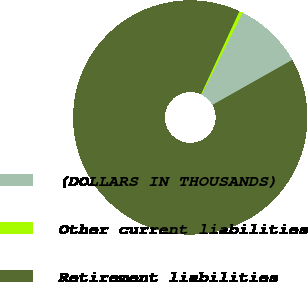Convert chart to OTSL. <chart><loc_0><loc_0><loc_500><loc_500><pie_chart><fcel>(DOLLARS IN THOUSANDS)<fcel>Other current liabilities<fcel>Retirement liabilities<nl><fcel>9.45%<fcel>0.49%<fcel>90.07%<nl></chart> 